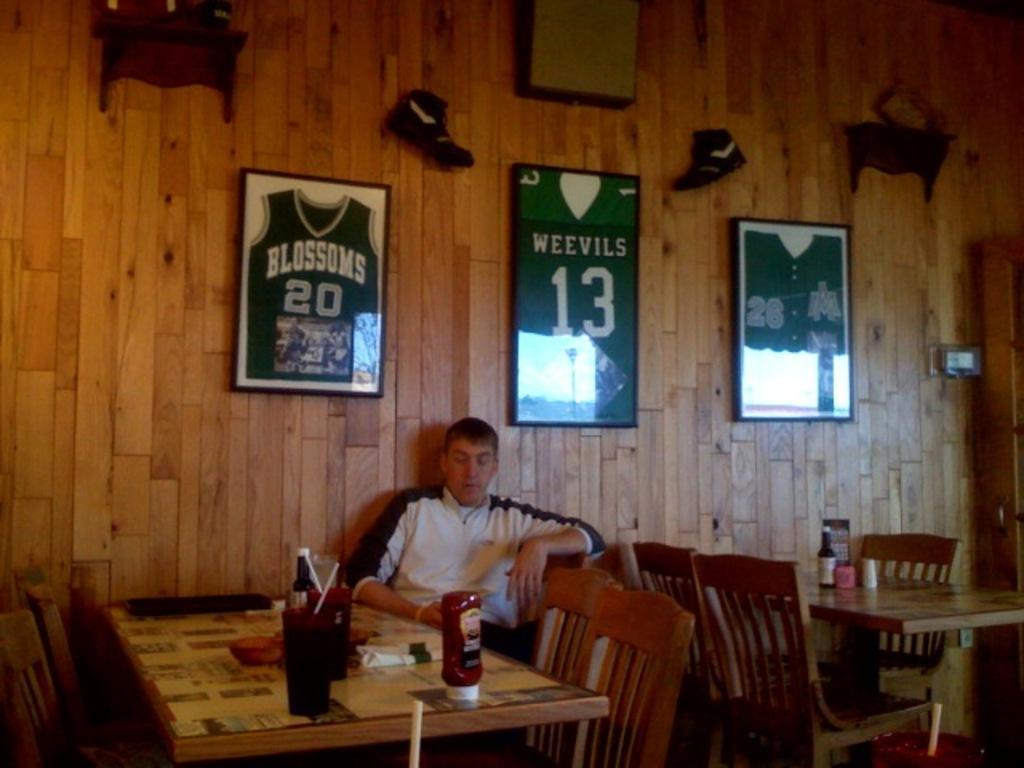In one or two sentences, can you explain what this image depicts? In this image i can see a man sitting on a chair there is a bottle on a table at the back ground i can see a frame and a wooden wall. 